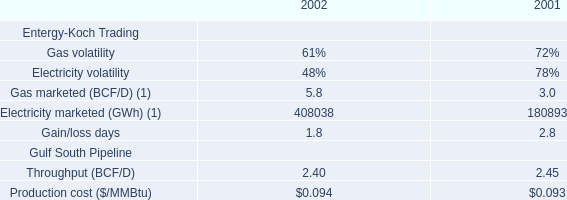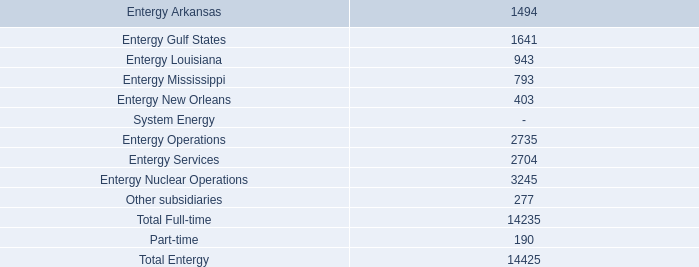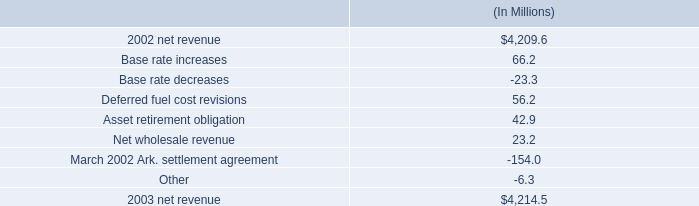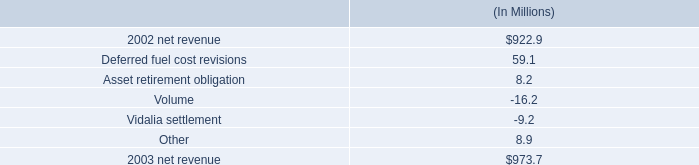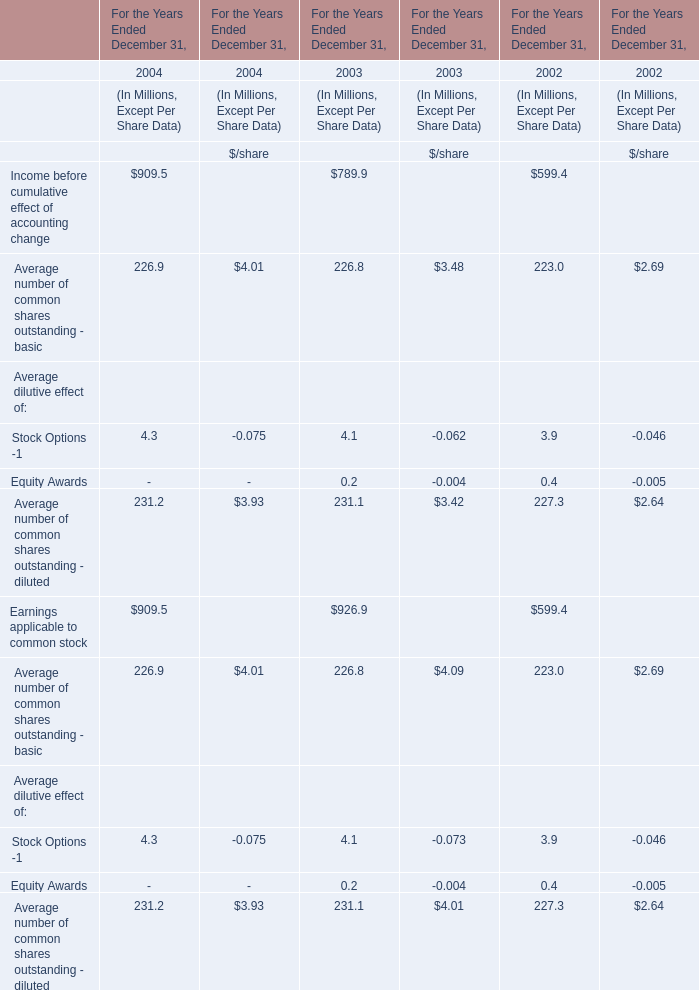What do all Average dilutive effect sum up without those Average dilutive effect smaller than 1.0, in 2003? (in Dollars In Millions) 
Answer: 4.1. 